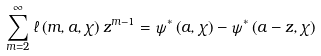Convert formula to latex. <formula><loc_0><loc_0><loc_500><loc_500>\sum _ { m = 2 } ^ { \infty } \ell \left ( m , a , \chi \right ) z ^ { m - 1 } = \psi ^ { \ast } \left ( a , \chi \right ) - \psi ^ { \ast } \left ( a - z , \chi \right )</formula> 